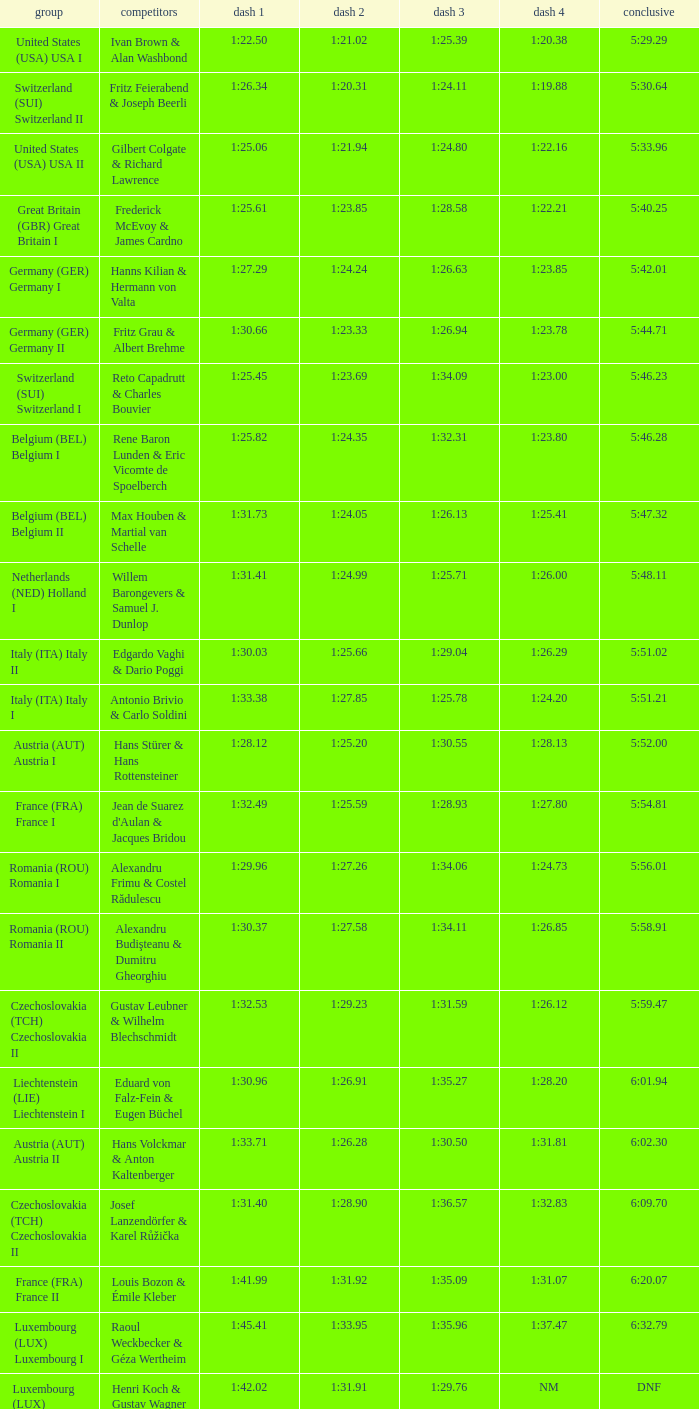Which Run 4 has Athletes of alexandru frimu & costel rădulescu? 1:24.73. 